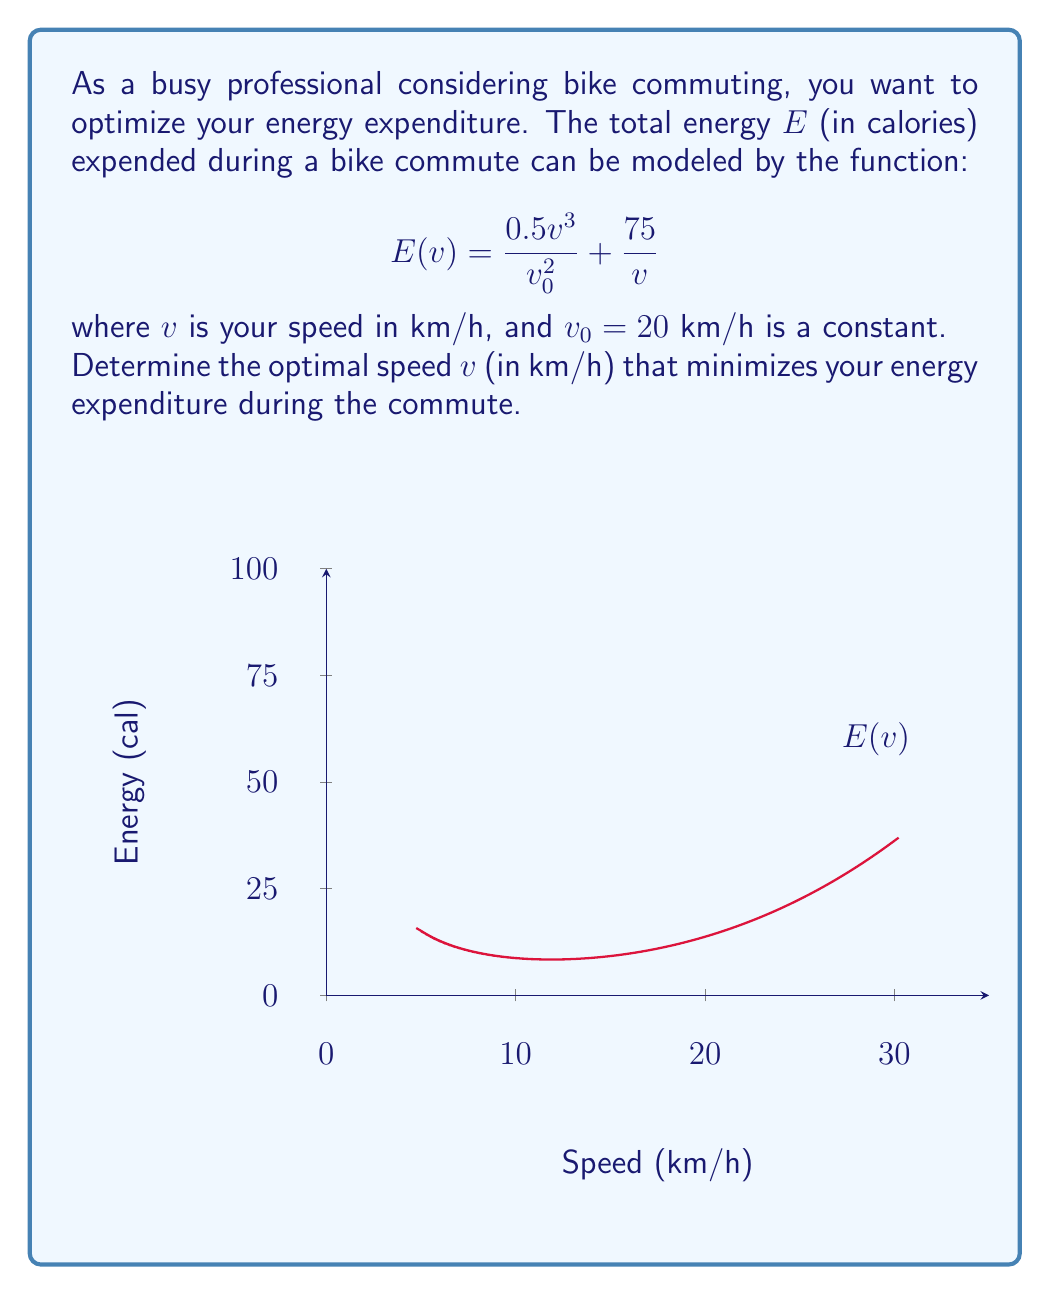Can you solve this math problem? To find the optimal speed that minimizes energy expenditure, we need to find the minimum point of the function $E(v)$. This can be done by following these steps:

1) First, we take the derivative of $E(v)$ with respect to $v$:

   $$E'(v) = \frac{d}{dv}\left(\frac{0.5v^3}{v_0^2} + \frac{75}{v}\right)$$
   $$E'(v) = \frac{1.5v^2}{v_0^2} - \frac{75}{v^2}$$

2) To find the minimum, we set $E'(v) = 0$ and solve for $v$:

   $$\frac{1.5v^2}{v_0^2} - \frac{75}{v^2} = 0$$

3) Multiply both sides by $v^2v_0^2$:

   $$1.5v^4 - 75v_0^2 = 0$$

4) Substitute $v_0 = 20$:

   $$1.5v^4 - 75(400) = 0$$
   $$1.5v^4 = 30000$$
   $$v^4 = 20000$$

5) Solve for $v$:

   $$v = \sqrt[4]{20000} \approx 11.87$$

6) To confirm this is a minimum, we can check that $E''(v) > 0$ at this point (which it is).

Therefore, the optimal speed to minimize energy expenditure is approximately 11.87 km/h.
Answer: $v \approx 11.87$ km/h 